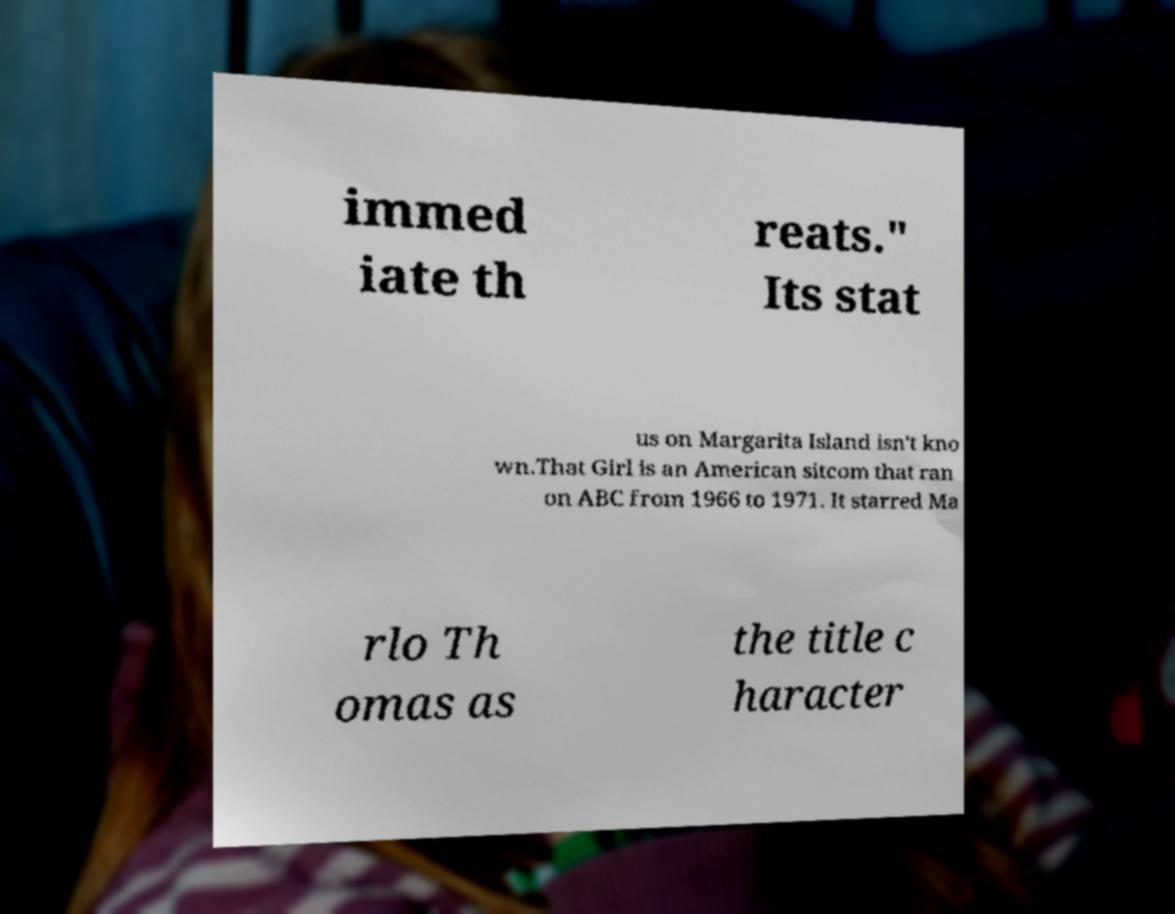Can you read and provide the text displayed in the image?This photo seems to have some interesting text. Can you extract and type it out for me? immed iate th reats." Its stat us on Margarita Island isn't kno wn.That Girl is an American sitcom that ran on ABC from 1966 to 1971. It starred Ma rlo Th omas as the title c haracter 